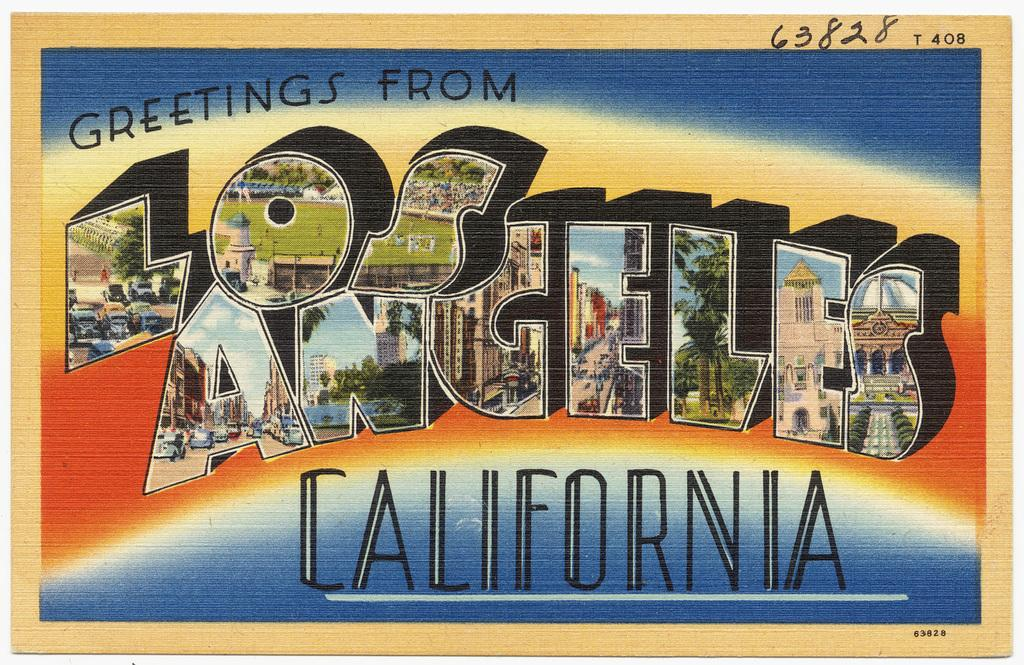<image>
Provide a brief description of the given image. Postcard for Los Angeles California with the number 408 on top. 